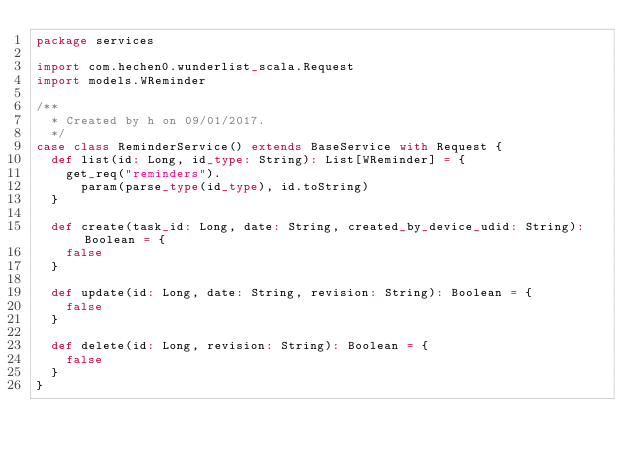<code> <loc_0><loc_0><loc_500><loc_500><_Scala_>package services

import com.hechen0.wunderlist_scala.Request
import models.WReminder

/**
  * Created by h on 09/01/2017.
  */
case class ReminderService() extends BaseService with Request {
  def list(id: Long, id_type: String): List[WReminder] = {
    get_req("reminders").
      param(parse_type(id_type), id.toString)
  }

  def create(task_id: Long, date: String, created_by_device_udid: String): Boolean = {
    false
  }

  def update(id: Long, date: String, revision: String): Boolean = {
    false
  }

  def delete(id: Long, revision: String): Boolean = {
    false
  }
}
</code> 